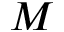Convert formula to latex. <formula><loc_0><loc_0><loc_500><loc_500>M</formula> 